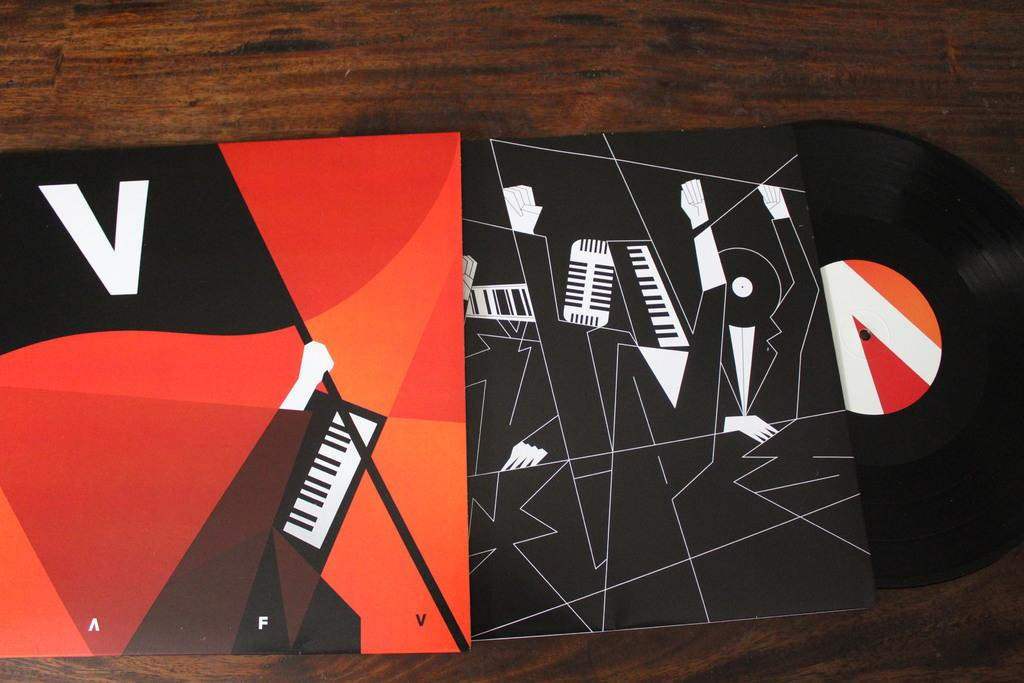What can be seen in the image? There is an object in the image. What colors are present on the object? The object has red, orange, black, and white colors. What is the object placed on? The object is on a brown surface. What is the income of the person who owns the object in the image? There is no information about the owner of the object or their income in the image. 